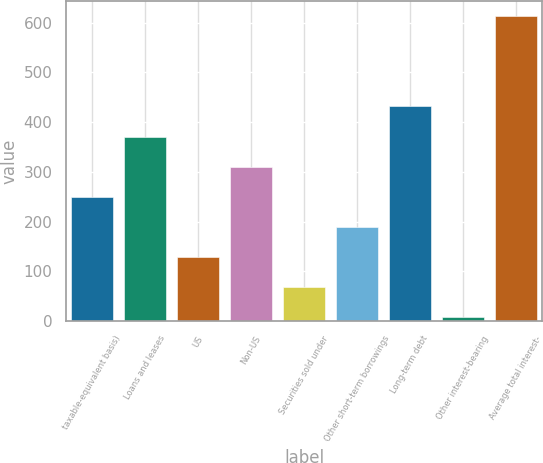Convert chart. <chart><loc_0><loc_0><loc_500><loc_500><bar_chart><fcel>taxable-equivalent basis)<fcel>Loans and leases<fcel>US<fcel>Non-US<fcel>Securities sold under<fcel>Other short-term borrowings<fcel>Long-term debt<fcel>Other interest-bearing<fcel>Average total interest-<nl><fcel>250<fcel>371<fcel>129<fcel>310.5<fcel>68.5<fcel>189.5<fcel>431.5<fcel>8<fcel>613<nl></chart> 